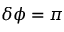<formula> <loc_0><loc_0><loc_500><loc_500>\delta \phi = \pi</formula> 